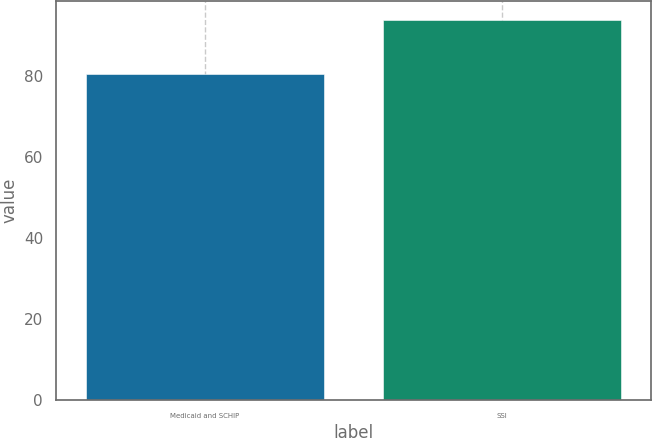Convert chart. <chart><loc_0><loc_0><loc_500><loc_500><bar_chart><fcel>Medicaid and SCHIP<fcel>SSI<nl><fcel>80.4<fcel>93.8<nl></chart> 